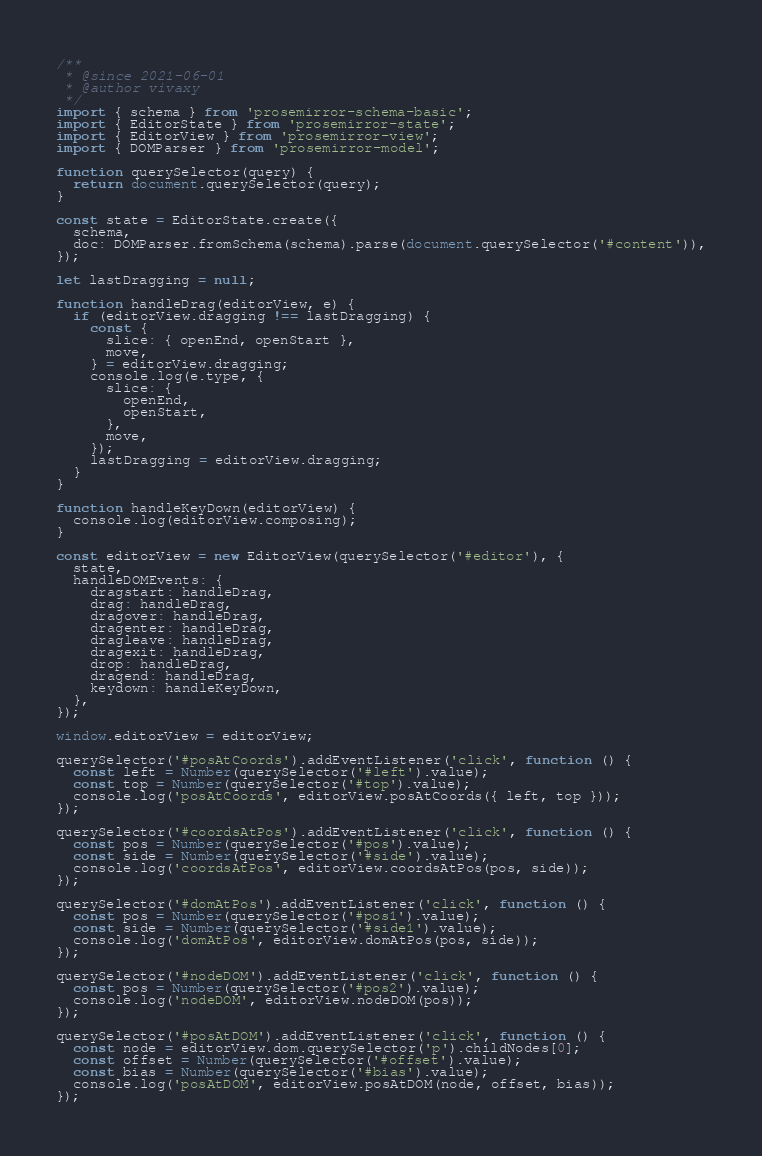Convert code to text. <code><loc_0><loc_0><loc_500><loc_500><_JavaScript_>/**
 * @since 2021-06-01
 * @author vivaxy
 */
import { schema } from 'prosemirror-schema-basic';
import { EditorState } from 'prosemirror-state';
import { EditorView } from 'prosemirror-view';
import { DOMParser } from 'prosemirror-model';

function querySelector(query) {
  return document.querySelector(query);
}

const state = EditorState.create({
  schema,
  doc: DOMParser.fromSchema(schema).parse(document.querySelector('#content')),
});

let lastDragging = null;

function handleDrag(editorView, e) {
  if (editorView.dragging !== lastDragging) {
    const {
      slice: { openEnd, openStart },
      move,
    } = editorView.dragging;
    console.log(e.type, {
      slice: {
        openEnd,
        openStart,
      },
      move,
    });
    lastDragging = editorView.dragging;
  }
}

function handleKeyDown(editorView) {
  console.log(editorView.composing);
}

const editorView = new EditorView(querySelector('#editor'), {
  state,
  handleDOMEvents: {
    dragstart: handleDrag,
    drag: handleDrag,
    dragover: handleDrag,
    dragenter: handleDrag,
    dragleave: handleDrag,
    dragexit: handleDrag,
    drop: handleDrag,
    dragend: handleDrag,
    keydown: handleKeyDown,
  },
});

window.editorView = editorView;

querySelector('#posAtCoords').addEventListener('click', function () {
  const left = Number(querySelector('#left').value);
  const top = Number(querySelector('#top').value);
  console.log('posAtCoords', editorView.posAtCoords({ left, top }));
});

querySelector('#coordsAtPos').addEventListener('click', function () {
  const pos = Number(querySelector('#pos').value);
  const side = Number(querySelector('#side').value);
  console.log('coordsAtPos', editorView.coordsAtPos(pos, side));
});

querySelector('#domAtPos').addEventListener('click', function () {
  const pos = Number(querySelector('#pos1').value);
  const side = Number(querySelector('#side1').value);
  console.log('domAtPos', editorView.domAtPos(pos, side));
});

querySelector('#nodeDOM').addEventListener('click', function () {
  const pos = Number(querySelector('#pos2').value);
  console.log('nodeDOM', editorView.nodeDOM(pos));
});

querySelector('#posAtDOM').addEventListener('click', function () {
  const node = editorView.dom.querySelector('p').childNodes[0];
  const offset = Number(querySelector('#offset').value);
  const bias = Number(querySelector('#bias').value);
  console.log('posAtDOM', editorView.posAtDOM(node, offset, bias));
});
</code> 